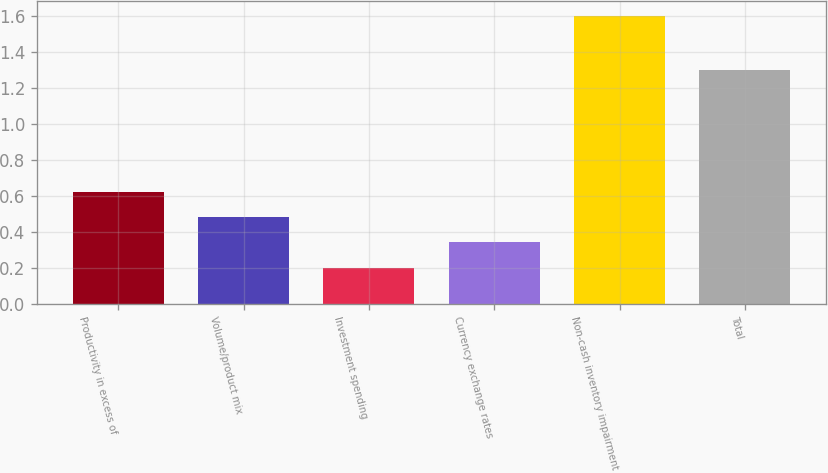Convert chart to OTSL. <chart><loc_0><loc_0><loc_500><loc_500><bar_chart><fcel>Productivity in excess of<fcel>Volume/product mix<fcel>Investment spending<fcel>Currency exchange rates<fcel>Non-cash inventory impairment<fcel>Total<nl><fcel>0.62<fcel>0.48<fcel>0.2<fcel>0.34<fcel>1.6<fcel>1.3<nl></chart> 